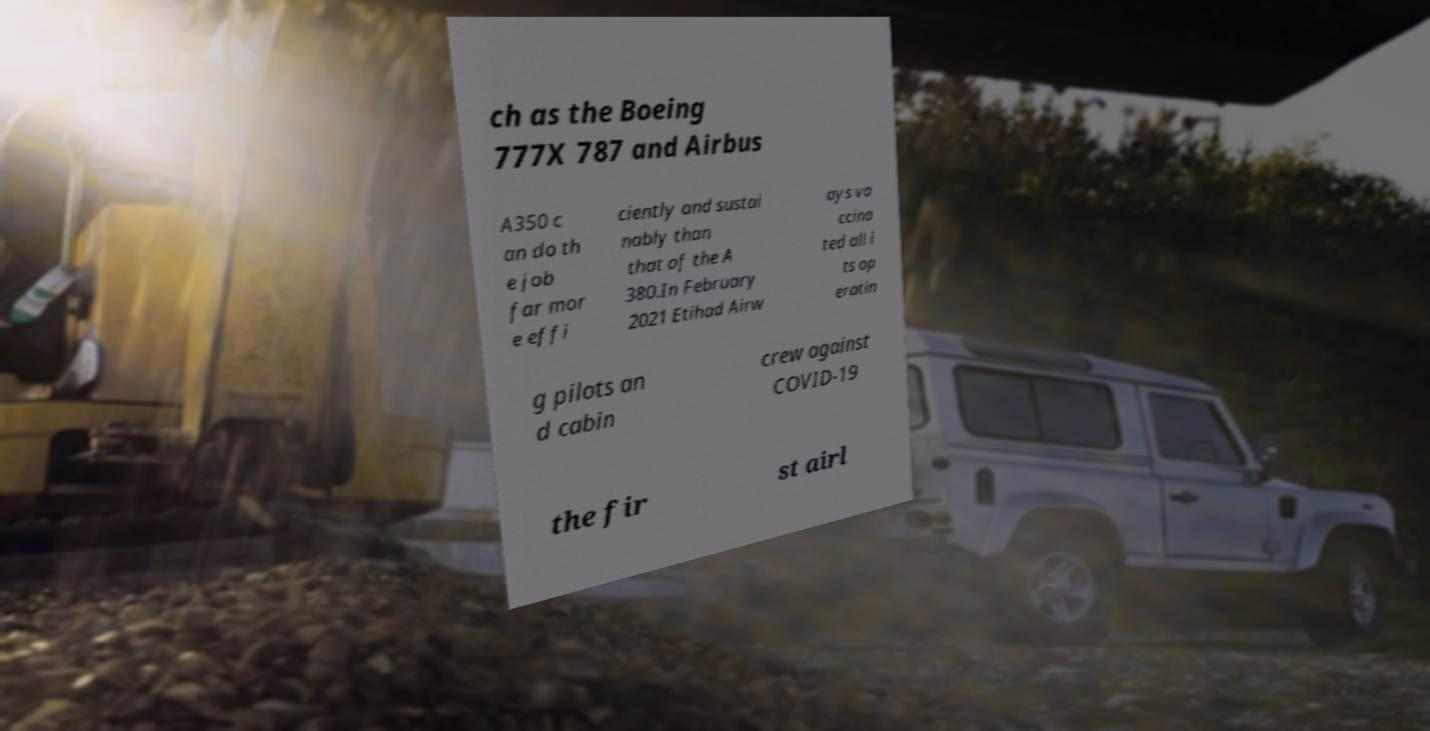Can you accurately transcribe the text from the provided image for me? ch as the Boeing 777X 787 and Airbus A350 c an do th e job far mor e effi ciently and sustai nably than that of the A 380.In February 2021 Etihad Airw ays va ccina ted all i ts op eratin g pilots an d cabin crew against COVID-19 the fir st airl 